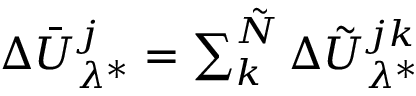Convert formula to latex. <formula><loc_0><loc_0><loc_500><loc_500>\begin{array} { r } { \Delta \bar { U } _ { \lambda ^ { * } } ^ { j } = \sum _ { k } ^ { \tilde { N } } \Delta \tilde { U } _ { \lambda ^ { * } } ^ { j k } } \end{array}</formula> 